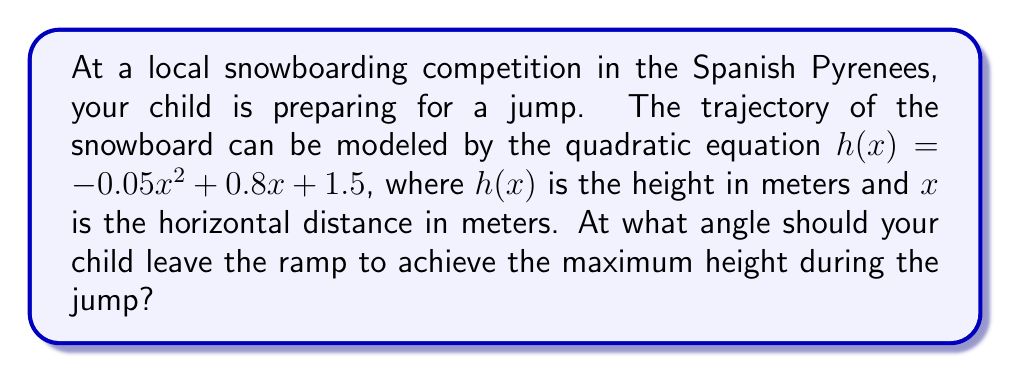Can you answer this question? To find the optimal angle for the snowboard jump, we need to determine the vertex of the parabola, which represents the highest point of the jump. The general form of a quadratic equation is $f(x) = ax^2 + bx + c$, where the vertex is at $x = -\frac{b}{2a}$.

Given equation: $h(x) = -0.05x^2 + 0.8x + 1.5$

Step 1: Identify $a$ and $b$
$a = -0.05$
$b = 0.8$

Step 2: Calculate $x$ coordinate of the vertex
$x = -\frac{b}{2a} = -\frac{0.8}{2(-0.05)} = \frac{0.8}{0.1} = 8$

Step 3: The $x$ coordinate represents the horizontal distance at which the maximum height is achieved. To find the angle, we need to calculate the slope of the tangent line at $x = 0$ (the starting point of the jump).

Step 4: The derivative of $h(x)$ gives us the slope at any point:
$h'(x) = -0.1x + 0.8$

Step 5: Evaluate the slope at $x = 0$:
$h'(0) = 0.8$

Step 6: The angle of the ramp is the arctangent of this slope:
$\theta = \arctan(0.8)$

Step 7: Convert to degrees:
$\theta = \arctan(0.8) \cdot \frac{180}{\pi} \approx 38.66°$
Answer: $38.66°$ 